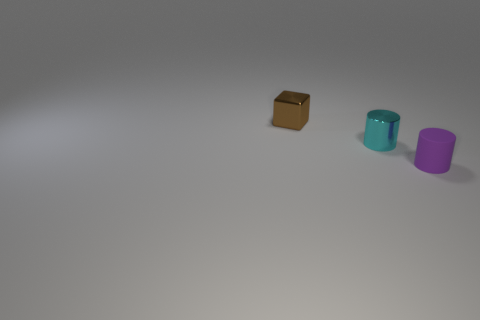Add 3 tiny red metallic balls. How many objects exist? 6 Subtract all cylinders. How many objects are left? 1 Subtract 0 gray cylinders. How many objects are left? 3 Subtract all big cyan cylinders. Subtract all shiny objects. How many objects are left? 1 Add 3 small objects. How many small objects are left? 6 Add 3 cyan things. How many cyan things exist? 4 